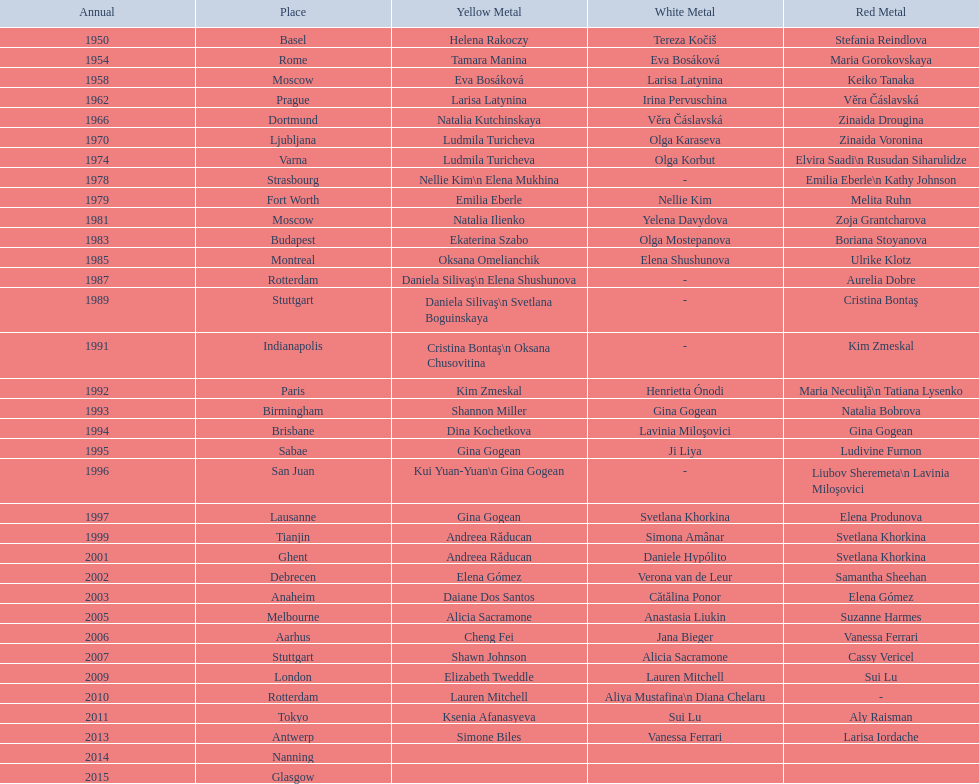As of 2013, what is the total number of floor exercise gold medals won by american women at the world championships? 5. 